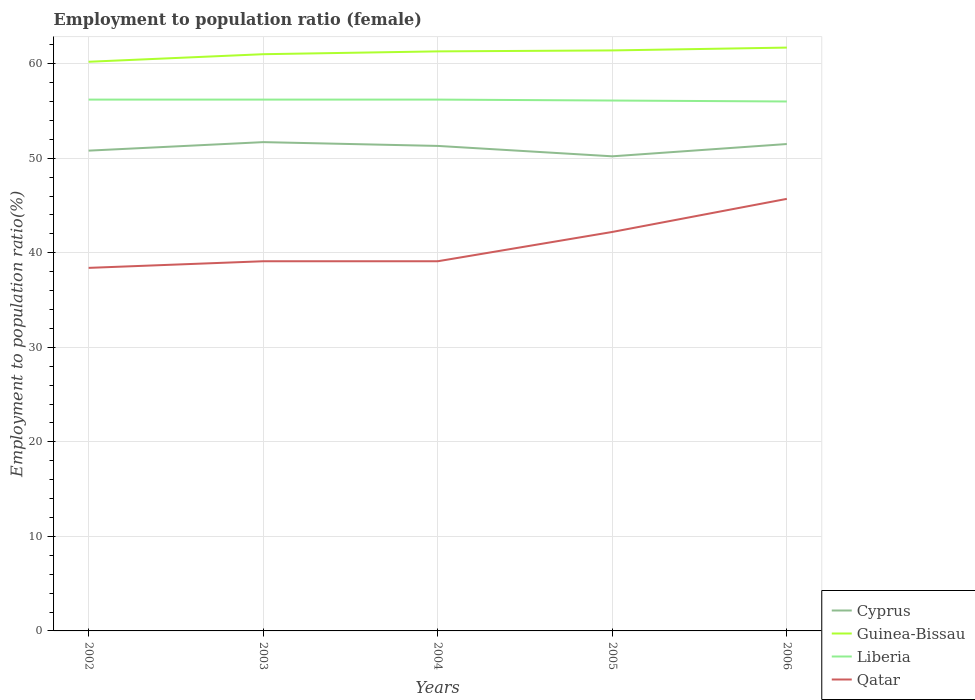How many different coloured lines are there?
Your answer should be compact. 4. Is the number of lines equal to the number of legend labels?
Provide a short and direct response. Yes. Across all years, what is the maximum employment to population ratio in Cyprus?
Provide a succinct answer. 50.2. In which year was the employment to population ratio in Cyprus maximum?
Give a very brief answer. 2005. What is the total employment to population ratio in Guinea-Bissau in the graph?
Your response must be concise. -1.2. What is the difference between the highest and the second highest employment to population ratio in Qatar?
Your answer should be compact. 7.3. What is the difference between the highest and the lowest employment to population ratio in Cyprus?
Your answer should be very brief. 3. How many lines are there?
Give a very brief answer. 4. Does the graph contain grids?
Provide a short and direct response. Yes. How many legend labels are there?
Give a very brief answer. 4. What is the title of the graph?
Offer a very short reply. Employment to population ratio (female). What is the label or title of the X-axis?
Your response must be concise. Years. What is the label or title of the Y-axis?
Give a very brief answer. Employment to population ratio(%). What is the Employment to population ratio(%) in Cyprus in 2002?
Your answer should be very brief. 50.8. What is the Employment to population ratio(%) of Guinea-Bissau in 2002?
Provide a short and direct response. 60.2. What is the Employment to population ratio(%) in Liberia in 2002?
Give a very brief answer. 56.2. What is the Employment to population ratio(%) in Qatar in 2002?
Keep it short and to the point. 38.4. What is the Employment to population ratio(%) in Cyprus in 2003?
Your response must be concise. 51.7. What is the Employment to population ratio(%) of Guinea-Bissau in 2003?
Provide a short and direct response. 61. What is the Employment to population ratio(%) in Liberia in 2003?
Make the answer very short. 56.2. What is the Employment to population ratio(%) in Qatar in 2003?
Offer a very short reply. 39.1. What is the Employment to population ratio(%) in Cyprus in 2004?
Give a very brief answer. 51.3. What is the Employment to population ratio(%) in Guinea-Bissau in 2004?
Provide a short and direct response. 61.3. What is the Employment to population ratio(%) in Liberia in 2004?
Offer a very short reply. 56.2. What is the Employment to population ratio(%) of Qatar in 2004?
Make the answer very short. 39.1. What is the Employment to population ratio(%) of Cyprus in 2005?
Keep it short and to the point. 50.2. What is the Employment to population ratio(%) of Guinea-Bissau in 2005?
Ensure brevity in your answer.  61.4. What is the Employment to population ratio(%) in Liberia in 2005?
Ensure brevity in your answer.  56.1. What is the Employment to population ratio(%) in Qatar in 2005?
Offer a very short reply. 42.2. What is the Employment to population ratio(%) in Cyprus in 2006?
Your response must be concise. 51.5. What is the Employment to population ratio(%) in Guinea-Bissau in 2006?
Your answer should be compact. 61.7. What is the Employment to population ratio(%) of Liberia in 2006?
Your response must be concise. 56. What is the Employment to population ratio(%) in Qatar in 2006?
Provide a short and direct response. 45.7. Across all years, what is the maximum Employment to population ratio(%) in Cyprus?
Your answer should be compact. 51.7. Across all years, what is the maximum Employment to population ratio(%) in Guinea-Bissau?
Offer a terse response. 61.7. Across all years, what is the maximum Employment to population ratio(%) in Liberia?
Provide a short and direct response. 56.2. Across all years, what is the maximum Employment to population ratio(%) in Qatar?
Provide a short and direct response. 45.7. Across all years, what is the minimum Employment to population ratio(%) in Cyprus?
Offer a terse response. 50.2. Across all years, what is the minimum Employment to population ratio(%) in Guinea-Bissau?
Your response must be concise. 60.2. Across all years, what is the minimum Employment to population ratio(%) in Liberia?
Keep it short and to the point. 56. Across all years, what is the minimum Employment to population ratio(%) in Qatar?
Give a very brief answer. 38.4. What is the total Employment to population ratio(%) of Cyprus in the graph?
Your answer should be compact. 255.5. What is the total Employment to population ratio(%) in Guinea-Bissau in the graph?
Your answer should be very brief. 305.6. What is the total Employment to population ratio(%) in Liberia in the graph?
Your response must be concise. 280.7. What is the total Employment to population ratio(%) in Qatar in the graph?
Your response must be concise. 204.5. What is the difference between the Employment to population ratio(%) in Cyprus in 2002 and that in 2003?
Offer a very short reply. -0.9. What is the difference between the Employment to population ratio(%) of Cyprus in 2002 and that in 2004?
Your answer should be very brief. -0.5. What is the difference between the Employment to population ratio(%) of Liberia in 2002 and that in 2004?
Provide a short and direct response. 0. What is the difference between the Employment to population ratio(%) in Liberia in 2002 and that in 2005?
Provide a short and direct response. 0.1. What is the difference between the Employment to population ratio(%) in Liberia in 2002 and that in 2006?
Provide a short and direct response. 0.2. What is the difference between the Employment to population ratio(%) of Qatar in 2003 and that in 2004?
Ensure brevity in your answer.  0. What is the difference between the Employment to population ratio(%) in Guinea-Bissau in 2003 and that in 2005?
Give a very brief answer. -0.4. What is the difference between the Employment to population ratio(%) in Liberia in 2003 and that in 2005?
Your response must be concise. 0.1. What is the difference between the Employment to population ratio(%) of Cyprus in 2003 and that in 2006?
Provide a succinct answer. 0.2. What is the difference between the Employment to population ratio(%) of Guinea-Bissau in 2003 and that in 2006?
Offer a terse response. -0.7. What is the difference between the Employment to population ratio(%) of Liberia in 2003 and that in 2006?
Your answer should be compact. 0.2. What is the difference between the Employment to population ratio(%) in Cyprus in 2004 and that in 2005?
Provide a succinct answer. 1.1. What is the difference between the Employment to population ratio(%) of Guinea-Bissau in 2004 and that in 2005?
Your answer should be compact. -0.1. What is the difference between the Employment to population ratio(%) in Guinea-Bissau in 2004 and that in 2006?
Your answer should be very brief. -0.4. What is the difference between the Employment to population ratio(%) of Cyprus in 2005 and that in 2006?
Ensure brevity in your answer.  -1.3. What is the difference between the Employment to population ratio(%) in Cyprus in 2002 and the Employment to population ratio(%) in Guinea-Bissau in 2003?
Provide a succinct answer. -10.2. What is the difference between the Employment to population ratio(%) in Guinea-Bissau in 2002 and the Employment to population ratio(%) in Liberia in 2003?
Your response must be concise. 4. What is the difference between the Employment to population ratio(%) in Guinea-Bissau in 2002 and the Employment to population ratio(%) in Qatar in 2003?
Provide a succinct answer. 21.1. What is the difference between the Employment to population ratio(%) in Liberia in 2002 and the Employment to population ratio(%) in Qatar in 2003?
Your answer should be very brief. 17.1. What is the difference between the Employment to population ratio(%) of Cyprus in 2002 and the Employment to population ratio(%) of Guinea-Bissau in 2004?
Keep it short and to the point. -10.5. What is the difference between the Employment to population ratio(%) of Cyprus in 2002 and the Employment to population ratio(%) of Liberia in 2004?
Your answer should be compact. -5.4. What is the difference between the Employment to population ratio(%) of Cyprus in 2002 and the Employment to population ratio(%) of Qatar in 2004?
Provide a short and direct response. 11.7. What is the difference between the Employment to population ratio(%) of Guinea-Bissau in 2002 and the Employment to population ratio(%) of Qatar in 2004?
Make the answer very short. 21.1. What is the difference between the Employment to population ratio(%) of Cyprus in 2002 and the Employment to population ratio(%) of Qatar in 2005?
Make the answer very short. 8.6. What is the difference between the Employment to population ratio(%) of Guinea-Bissau in 2002 and the Employment to population ratio(%) of Liberia in 2005?
Your answer should be very brief. 4.1. What is the difference between the Employment to population ratio(%) in Guinea-Bissau in 2002 and the Employment to population ratio(%) in Qatar in 2005?
Give a very brief answer. 18. What is the difference between the Employment to population ratio(%) of Cyprus in 2002 and the Employment to population ratio(%) of Guinea-Bissau in 2006?
Offer a very short reply. -10.9. What is the difference between the Employment to population ratio(%) of Cyprus in 2002 and the Employment to population ratio(%) of Qatar in 2006?
Keep it short and to the point. 5.1. What is the difference between the Employment to population ratio(%) in Guinea-Bissau in 2002 and the Employment to population ratio(%) in Liberia in 2006?
Give a very brief answer. 4.2. What is the difference between the Employment to population ratio(%) in Guinea-Bissau in 2002 and the Employment to population ratio(%) in Qatar in 2006?
Your answer should be compact. 14.5. What is the difference between the Employment to population ratio(%) of Liberia in 2002 and the Employment to population ratio(%) of Qatar in 2006?
Provide a short and direct response. 10.5. What is the difference between the Employment to population ratio(%) in Cyprus in 2003 and the Employment to population ratio(%) in Guinea-Bissau in 2004?
Make the answer very short. -9.6. What is the difference between the Employment to population ratio(%) in Cyprus in 2003 and the Employment to population ratio(%) in Qatar in 2004?
Make the answer very short. 12.6. What is the difference between the Employment to population ratio(%) of Guinea-Bissau in 2003 and the Employment to population ratio(%) of Liberia in 2004?
Provide a short and direct response. 4.8. What is the difference between the Employment to population ratio(%) in Guinea-Bissau in 2003 and the Employment to population ratio(%) in Qatar in 2004?
Provide a succinct answer. 21.9. What is the difference between the Employment to population ratio(%) of Liberia in 2003 and the Employment to population ratio(%) of Qatar in 2004?
Ensure brevity in your answer.  17.1. What is the difference between the Employment to population ratio(%) of Cyprus in 2003 and the Employment to population ratio(%) of Guinea-Bissau in 2005?
Your response must be concise. -9.7. What is the difference between the Employment to population ratio(%) of Cyprus in 2003 and the Employment to population ratio(%) of Qatar in 2005?
Offer a very short reply. 9.5. What is the difference between the Employment to population ratio(%) of Guinea-Bissau in 2003 and the Employment to population ratio(%) of Liberia in 2005?
Offer a terse response. 4.9. What is the difference between the Employment to population ratio(%) in Liberia in 2003 and the Employment to population ratio(%) in Qatar in 2005?
Make the answer very short. 14. What is the difference between the Employment to population ratio(%) of Cyprus in 2003 and the Employment to population ratio(%) of Guinea-Bissau in 2006?
Keep it short and to the point. -10. What is the difference between the Employment to population ratio(%) of Cyprus in 2003 and the Employment to population ratio(%) of Qatar in 2006?
Your answer should be very brief. 6. What is the difference between the Employment to population ratio(%) of Guinea-Bissau in 2003 and the Employment to population ratio(%) of Liberia in 2006?
Keep it short and to the point. 5. What is the difference between the Employment to population ratio(%) of Guinea-Bissau in 2003 and the Employment to population ratio(%) of Qatar in 2006?
Give a very brief answer. 15.3. What is the difference between the Employment to population ratio(%) of Liberia in 2003 and the Employment to population ratio(%) of Qatar in 2006?
Ensure brevity in your answer.  10.5. What is the difference between the Employment to population ratio(%) of Cyprus in 2004 and the Employment to population ratio(%) of Qatar in 2005?
Offer a very short reply. 9.1. What is the difference between the Employment to population ratio(%) in Guinea-Bissau in 2004 and the Employment to population ratio(%) in Liberia in 2005?
Offer a terse response. 5.2. What is the difference between the Employment to population ratio(%) of Cyprus in 2004 and the Employment to population ratio(%) of Guinea-Bissau in 2006?
Make the answer very short. -10.4. What is the difference between the Employment to population ratio(%) in Cyprus in 2004 and the Employment to population ratio(%) in Liberia in 2006?
Give a very brief answer. -4.7. What is the difference between the Employment to population ratio(%) in Cyprus in 2004 and the Employment to population ratio(%) in Qatar in 2006?
Offer a very short reply. 5.6. What is the difference between the Employment to population ratio(%) in Guinea-Bissau in 2004 and the Employment to population ratio(%) in Liberia in 2006?
Your response must be concise. 5.3. What is the difference between the Employment to population ratio(%) in Guinea-Bissau in 2004 and the Employment to population ratio(%) in Qatar in 2006?
Offer a terse response. 15.6. What is the difference between the Employment to population ratio(%) in Liberia in 2004 and the Employment to population ratio(%) in Qatar in 2006?
Provide a succinct answer. 10.5. What is the difference between the Employment to population ratio(%) of Cyprus in 2005 and the Employment to population ratio(%) of Guinea-Bissau in 2006?
Offer a very short reply. -11.5. What is the difference between the Employment to population ratio(%) of Guinea-Bissau in 2005 and the Employment to population ratio(%) of Liberia in 2006?
Your response must be concise. 5.4. What is the difference between the Employment to population ratio(%) in Guinea-Bissau in 2005 and the Employment to population ratio(%) in Qatar in 2006?
Offer a very short reply. 15.7. What is the difference between the Employment to population ratio(%) in Liberia in 2005 and the Employment to population ratio(%) in Qatar in 2006?
Give a very brief answer. 10.4. What is the average Employment to population ratio(%) in Cyprus per year?
Make the answer very short. 51.1. What is the average Employment to population ratio(%) of Guinea-Bissau per year?
Provide a short and direct response. 61.12. What is the average Employment to population ratio(%) of Liberia per year?
Offer a terse response. 56.14. What is the average Employment to population ratio(%) in Qatar per year?
Your response must be concise. 40.9. In the year 2002, what is the difference between the Employment to population ratio(%) of Cyprus and Employment to population ratio(%) of Guinea-Bissau?
Make the answer very short. -9.4. In the year 2002, what is the difference between the Employment to population ratio(%) in Guinea-Bissau and Employment to population ratio(%) in Qatar?
Offer a very short reply. 21.8. In the year 2003, what is the difference between the Employment to population ratio(%) in Cyprus and Employment to population ratio(%) in Guinea-Bissau?
Offer a terse response. -9.3. In the year 2003, what is the difference between the Employment to population ratio(%) in Cyprus and Employment to population ratio(%) in Liberia?
Offer a terse response. -4.5. In the year 2003, what is the difference between the Employment to population ratio(%) of Cyprus and Employment to population ratio(%) of Qatar?
Your answer should be compact. 12.6. In the year 2003, what is the difference between the Employment to population ratio(%) of Guinea-Bissau and Employment to population ratio(%) of Qatar?
Provide a succinct answer. 21.9. In the year 2004, what is the difference between the Employment to population ratio(%) in Cyprus and Employment to population ratio(%) in Guinea-Bissau?
Make the answer very short. -10. In the year 2004, what is the difference between the Employment to population ratio(%) in Guinea-Bissau and Employment to population ratio(%) in Liberia?
Offer a very short reply. 5.1. In the year 2004, what is the difference between the Employment to population ratio(%) in Liberia and Employment to population ratio(%) in Qatar?
Offer a terse response. 17.1. In the year 2005, what is the difference between the Employment to population ratio(%) in Guinea-Bissau and Employment to population ratio(%) in Liberia?
Offer a terse response. 5.3. In the year 2005, what is the difference between the Employment to population ratio(%) in Guinea-Bissau and Employment to population ratio(%) in Qatar?
Provide a short and direct response. 19.2. In the year 2005, what is the difference between the Employment to population ratio(%) of Liberia and Employment to population ratio(%) of Qatar?
Your answer should be very brief. 13.9. In the year 2006, what is the difference between the Employment to population ratio(%) of Cyprus and Employment to population ratio(%) of Liberia?
Ensure brevity in your answer.  -4.5. In the year 2006, what is the difference between the Employment to population ratio(%) in Cyprus and Employment to population ratio(%) in Qatar?
Ensure brevity in your answer.  5.8. In the year 2006, what is the difference between the Employment to population ratio(%) in Guinea-Bissau and Employment to population ratio(%) in Liberia?
Your response must be concise. 5.7. In the year 2006, what is the difference between the Employment to population ratio(%) in Liberia and Employment to population ratio(%) in Qatar?
Offer a terse response. 10.3. What is the ratio of the Employment to population ratio(%) of Cyprus in 2002 to that in 2003?
Give a very brief answer. 0.98. What is the ratio of the Employment to population ratio(%) of Guinea-Bissau in 2002 to that in 2003?
Keep it short and to the point. 0.99. What is the ratio of the Employment to population ratio(%) in Qatar in 2002 to that in 2003?
Offer a terse response. 0.98. What is the ratio of the Employment to population ratio(%) of Cyprus in 2002 to that in 2004?
Your response must be concise. 0.99. What is the ratio of the Employment to population ratio(%) of Guinea-Bissau in 2002 to that in 2004?
Your response must be concise. 0.98. What is the ratio of the Employment to population ratio(%) of Liberia in 2002 to that in 2004?
Make the answer very short. 1. What is the ratio of the Employment to population ratio(%) in Qatar in 2002 to that in 2004?
Provide a succinct answer. 0.98. What is the ratio of the Employment to population ratio(%) of Guinea-Bissau in 2002 to that in 2005?
Make the answer very short. 0.98. What is the ratio of the Employment to population ratio(%) of Liberia in 2002 to that in 2005?
Offer a terse response. 1. What is the ratio of the Employment to population ratio(%) of Qatar in 2002 to that in 2005?
Give a very brief answer. 0.91. What is the ratio of the Employment to population ratio(%) in Cyprus in 2002 to that in 2006?
Your response must be concise. 0.99. What is the ratio of the Employment to population ratio(%) of Guinea-Bissau in 2002 to that in 2006?
Keep it short and to the point. 0.98. What is the ratio of the Employment to population ratio(%) of Qatar in 2002 to that in 2006?
Your answer should be very brief. 0.84. What is the ratio of the Employment to population ratio(%) in Cyprus in 2003 to that in 2004?
Make the answer very short. 1.01. What is the ratio of the Employment to population ratio(%) in Qatar in 2003 to that in 2004?
Your answer should be compact. 1. What is the ratio of the Employment to population ratio(%) in Cyprus in 2003 to that in 2005?
Your response must be concise. 1.03. What is the ratio of the Employment to population ratio(%) of Guinea-Bissau in 2003 to that in 2005?
Make the answer very short. 0.99. What is the ratio of the Employment to population ratio(%) in Qatar in 2003 to that in 2005?
Ensure brevity in your answer.  0.93. What is the ratio of the Employment to population ratio(%) of Cyprus in 2003 to that in 2006?
Your answer should be very brief. 1. What is the ratio of the Employment to population ratio(%) in Guinea-Bissau in 2003 to that in 2006?
Give a very brief answer. 0.99. What is the ratio of the Employment to population ratio(%) in Qatar in 2003 to that in 2006?
Keep it short and to the point. 0.86. What is the ratio of the Employment to population ratio(%) of Cyprus in 2004 to that in 2005?
Offer a terse response. 1.02. What is the ratio of the Employment to population ratio(%) in Qatar in 2004 to that in 2005?
Offer a very short reply. 0.93. What is the ratio of the Employment to population ratio(%) in Guinea-Bissau in 2004 to that in 2006?
Keep it short and to the point. 0.99. What is the ratio of the Employment to population ratio(%) of Liberia in 2004 to that in 2006?
Provide a short and direct response. 1. What is the ratio of the Employment to population ratio(%) of Qatar in 2004 to that in 2006?
Offer a very short reply. 0.86. What is the ratio of the Employment to population ratio(%) in Cyprus in 2005 to that in 2006?
Your response must be concise. 0.97. What is the ratio of the Employment to population ratio(%) in Qatar in 2005 to that in 2006?
Provide a short and direct response. 0.92. What is the difference between the highest and the second highest Employment to population ratio(%) in Liberia?
Offer a very short reply. 0. What is the difference between the highest and the lowest Employment to population ratio(%) in Cyprus?
Your response must be concise. 1.5. What is the difference between the highest and the lowest Employment to population ratio(%) in Guinea-Bissau?
Your answer should be compact. 1.5. What is the difference between the highest and the lowest Employment to population ratio(%) in Liberia?
Offer a terse response. 0.2. 